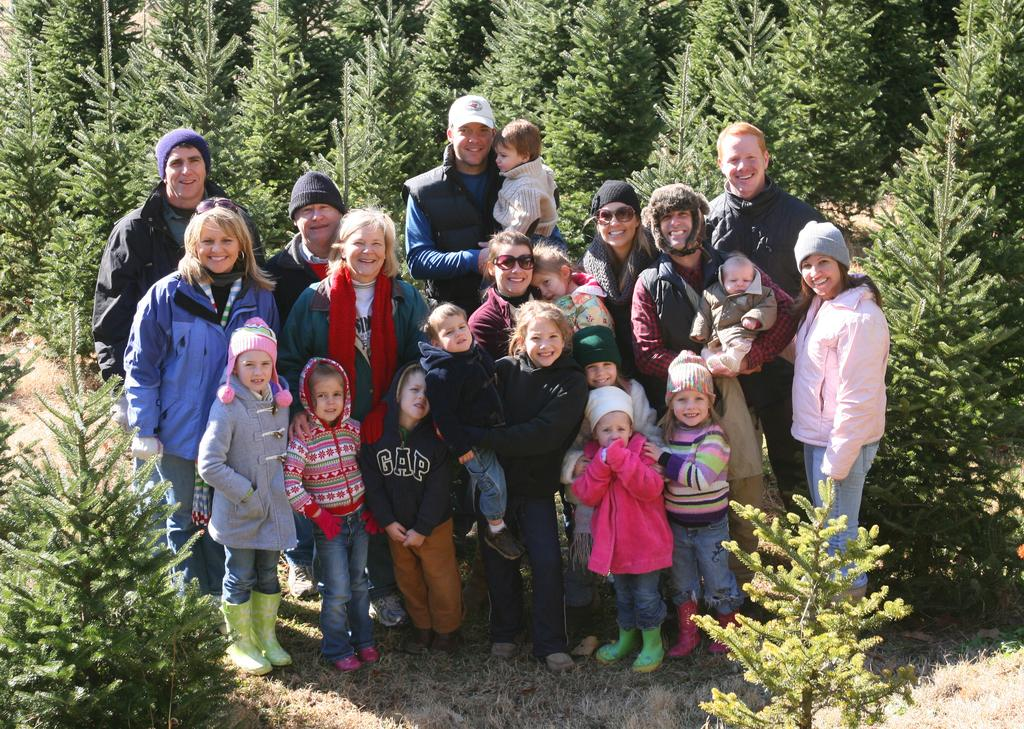What is happening in the middle of the image? There are people standing in the middle of the image. How are the people in the image feeling? The people are smiling in the image. What can be seen in the background of the image? There are trees visible behind the people. What type of glue is being used to hold the playground equipment together in the image? There is no playground equipment or glue present in the image. 